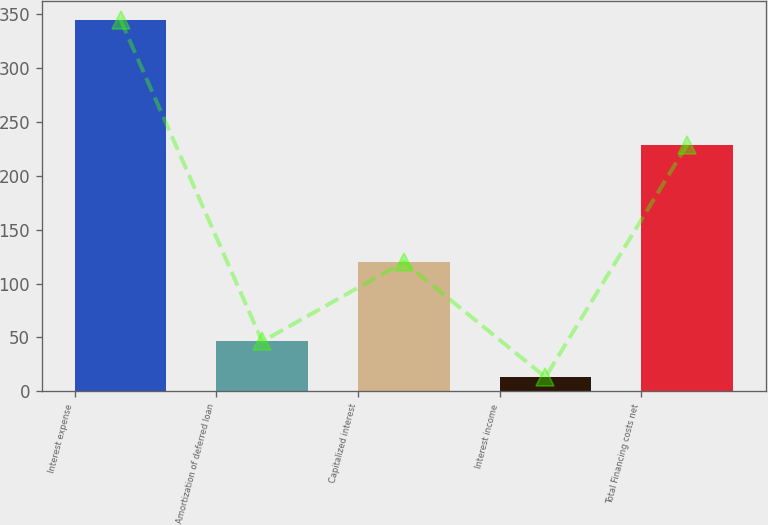<chart> <loc_0><loc_0><loc_500><loc_500><bar_chart><fcel>Interest expense<fcel>Amortization of deferred loan<fcel>Capitalized interest<fcel>Interest income<fcel>Total Financing costs net<nl><fcel>345<fcel>46.2<fcel>120<fcel>13<fcel>229<nl></chart> 